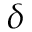<formula> <loc_0><loc_0><loc_500><loc_500>\delta</formula> 